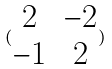<formula> <loc_0><loc_0><loc_500><loc_500>( \begin{matrix} 2 & - 2 \\ - 1 & 2 \end{matrix} )</formula> 